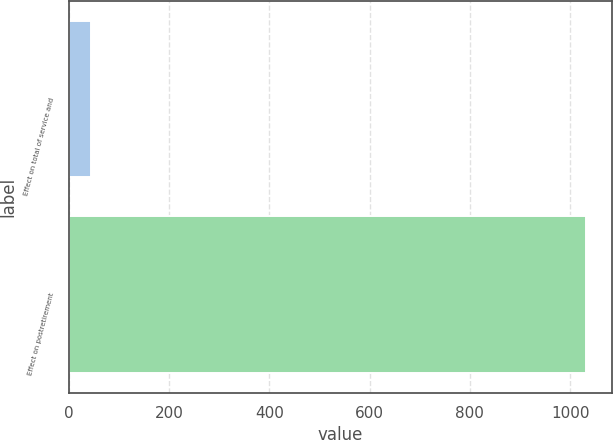Convert chart. <chart><loc_0><loc_0><loc_500><loc_500><bar_chart><fcel>Effect on total of service and<fcel>Effect on postretirement<nl><fcel>44<fcel>1031<nl></chart> 